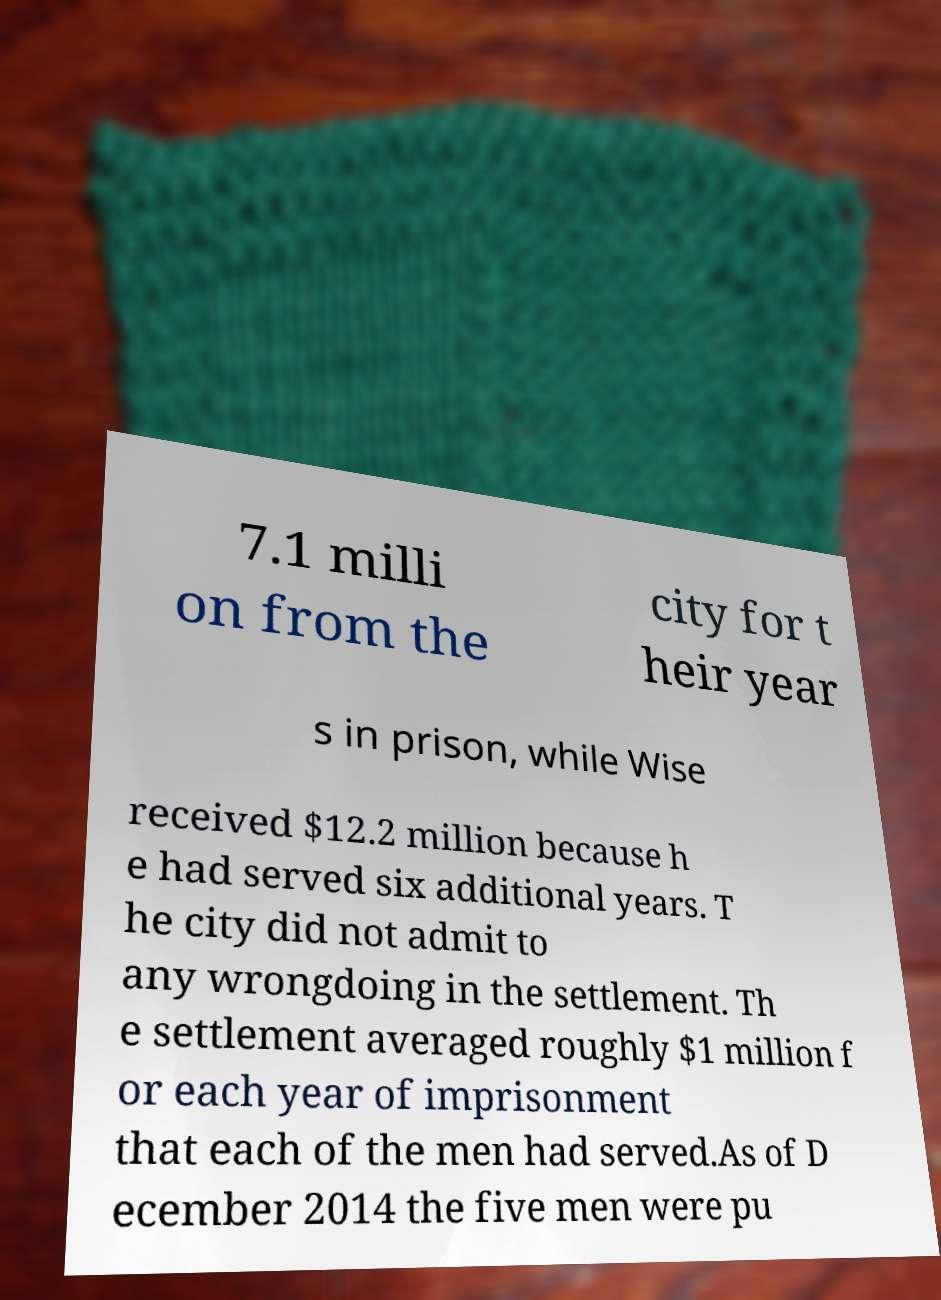Can you read and provide the text displayed in the image?This photo seems to have some interesting text. Can you extract and type it out for me? 7.1 milli on from the city for t heir year s in prison, while Wise received $12.2 million because h e had served six additional years. T he city did not admit to any wrongdoing in the settlement. Th e settlement averaged roughly $1 million f or each year of imprisonment that each of the men had served.As of D ecember 2014 the five men were pu 